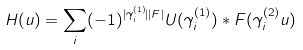<formula> <loc_0><loc_0><loc_500><loc_500>H ( u ) = \sum _ { i } ( - 1 ) ^ { | \gamma _ { i } ^ { ( 1 ) } | | F | } U ( \gamma _ { i } ^ { ( 1 ) } ) * F ( \gamma _ { i } ^ { ( 2 ) } u )</formula> 